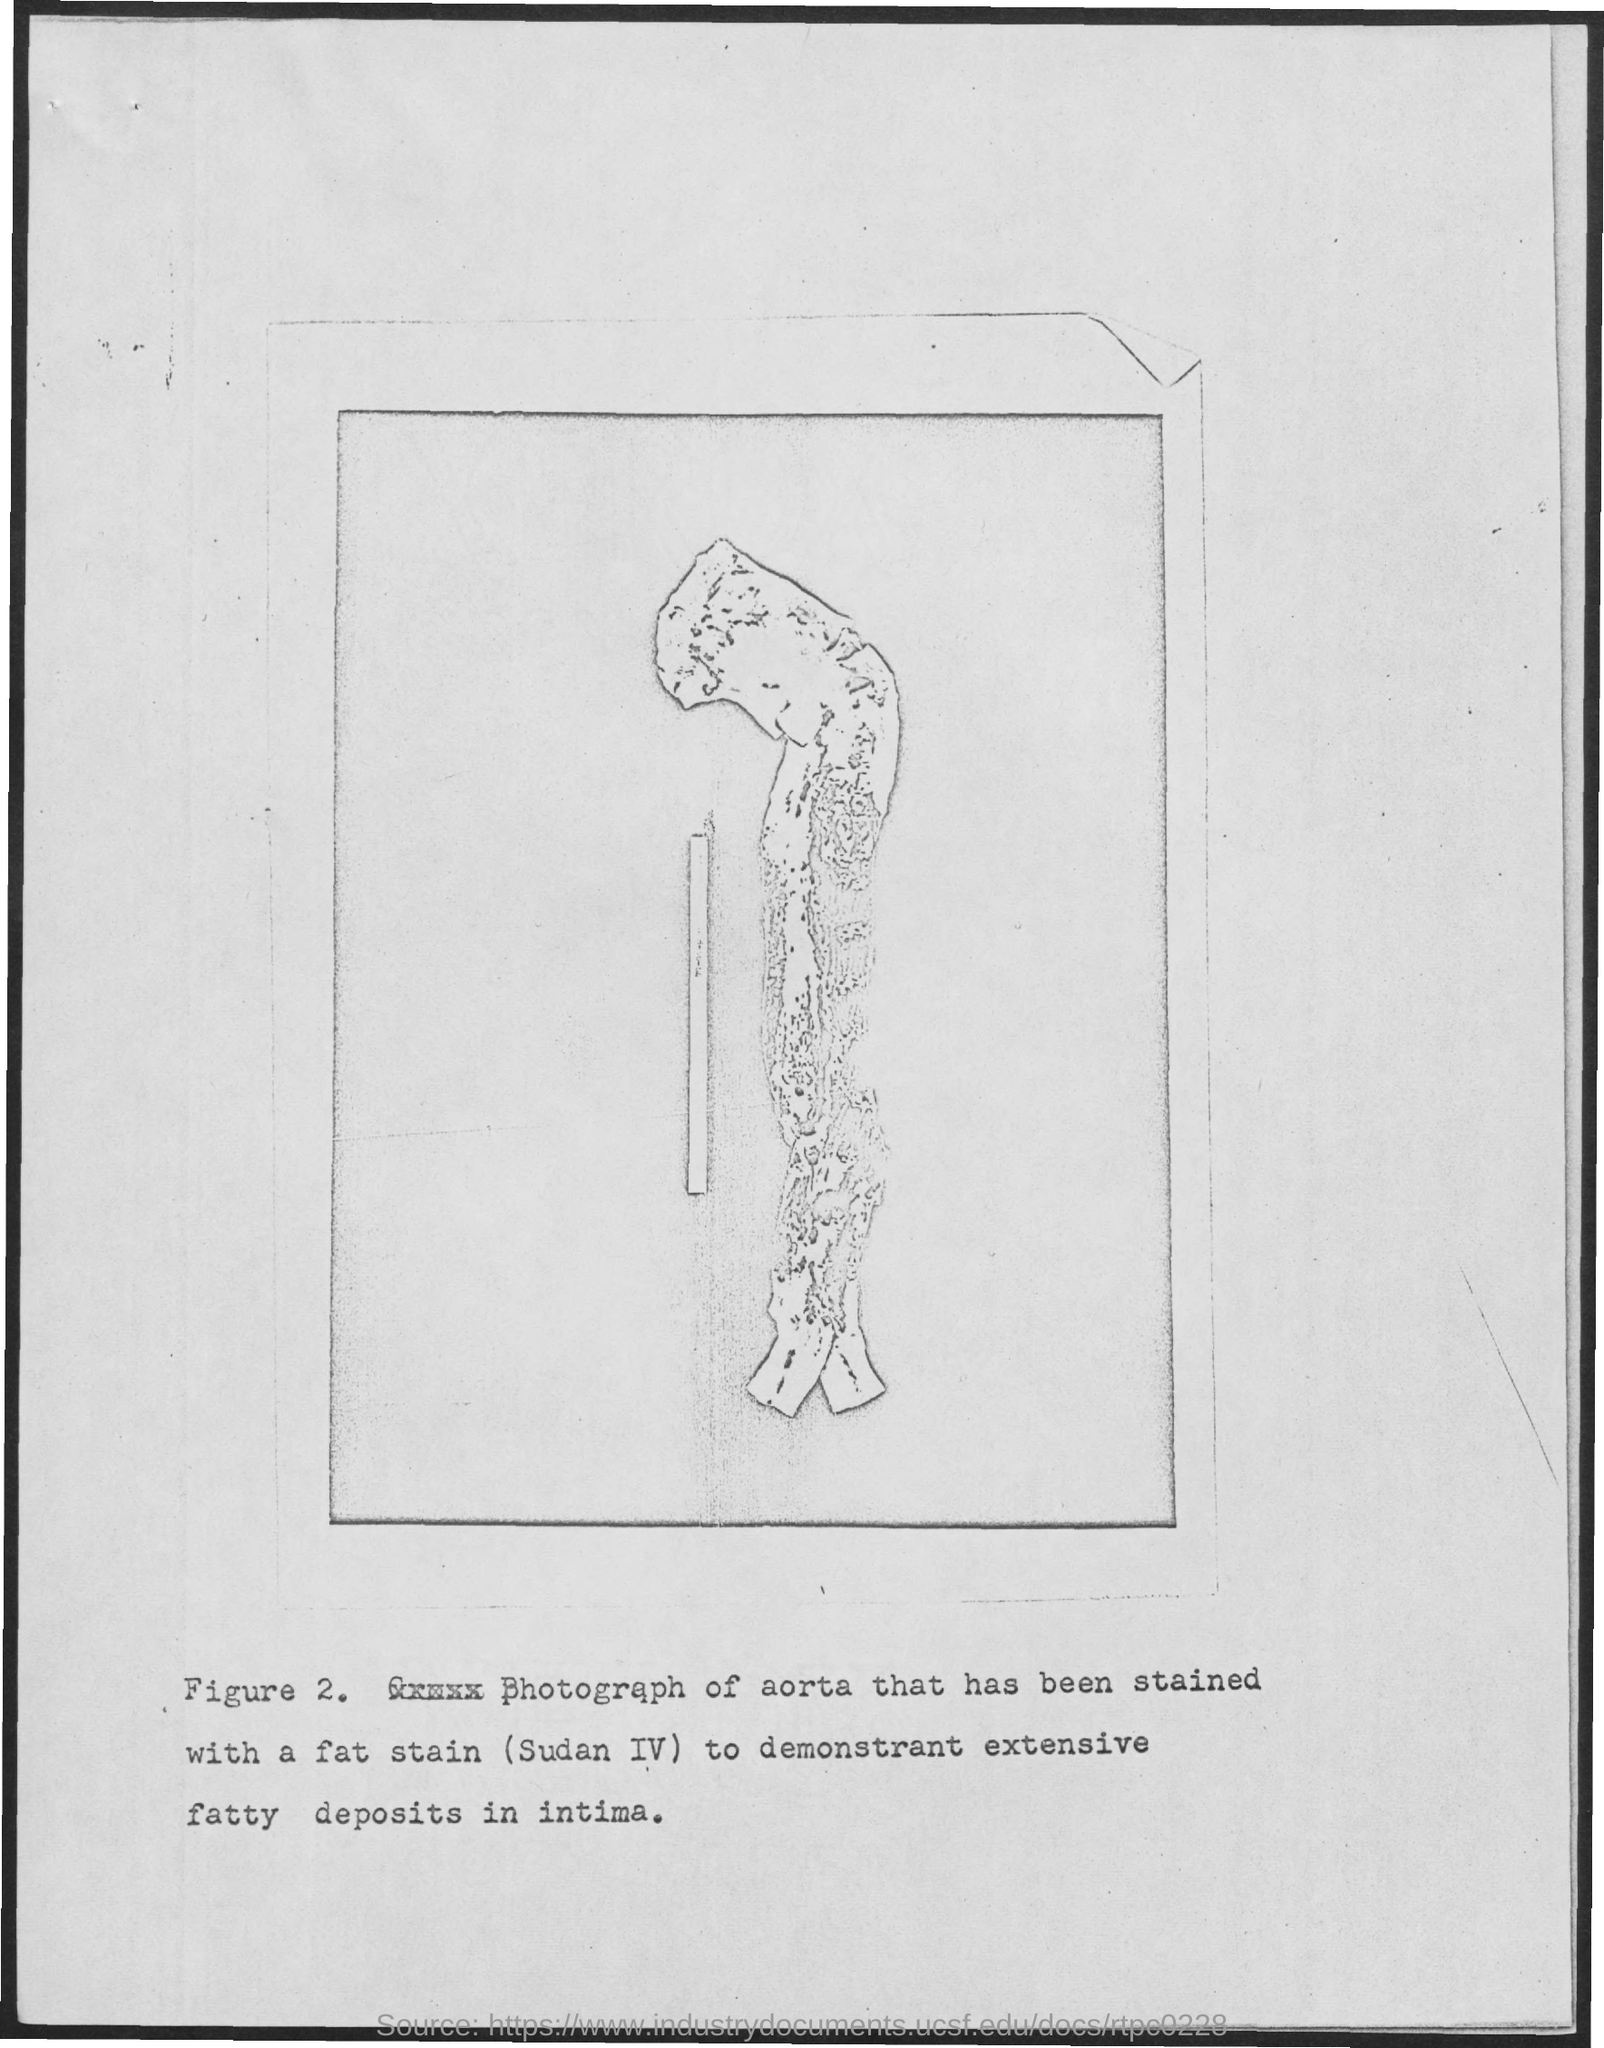What is the number of figure?
Provide a succinct answer. 2. 